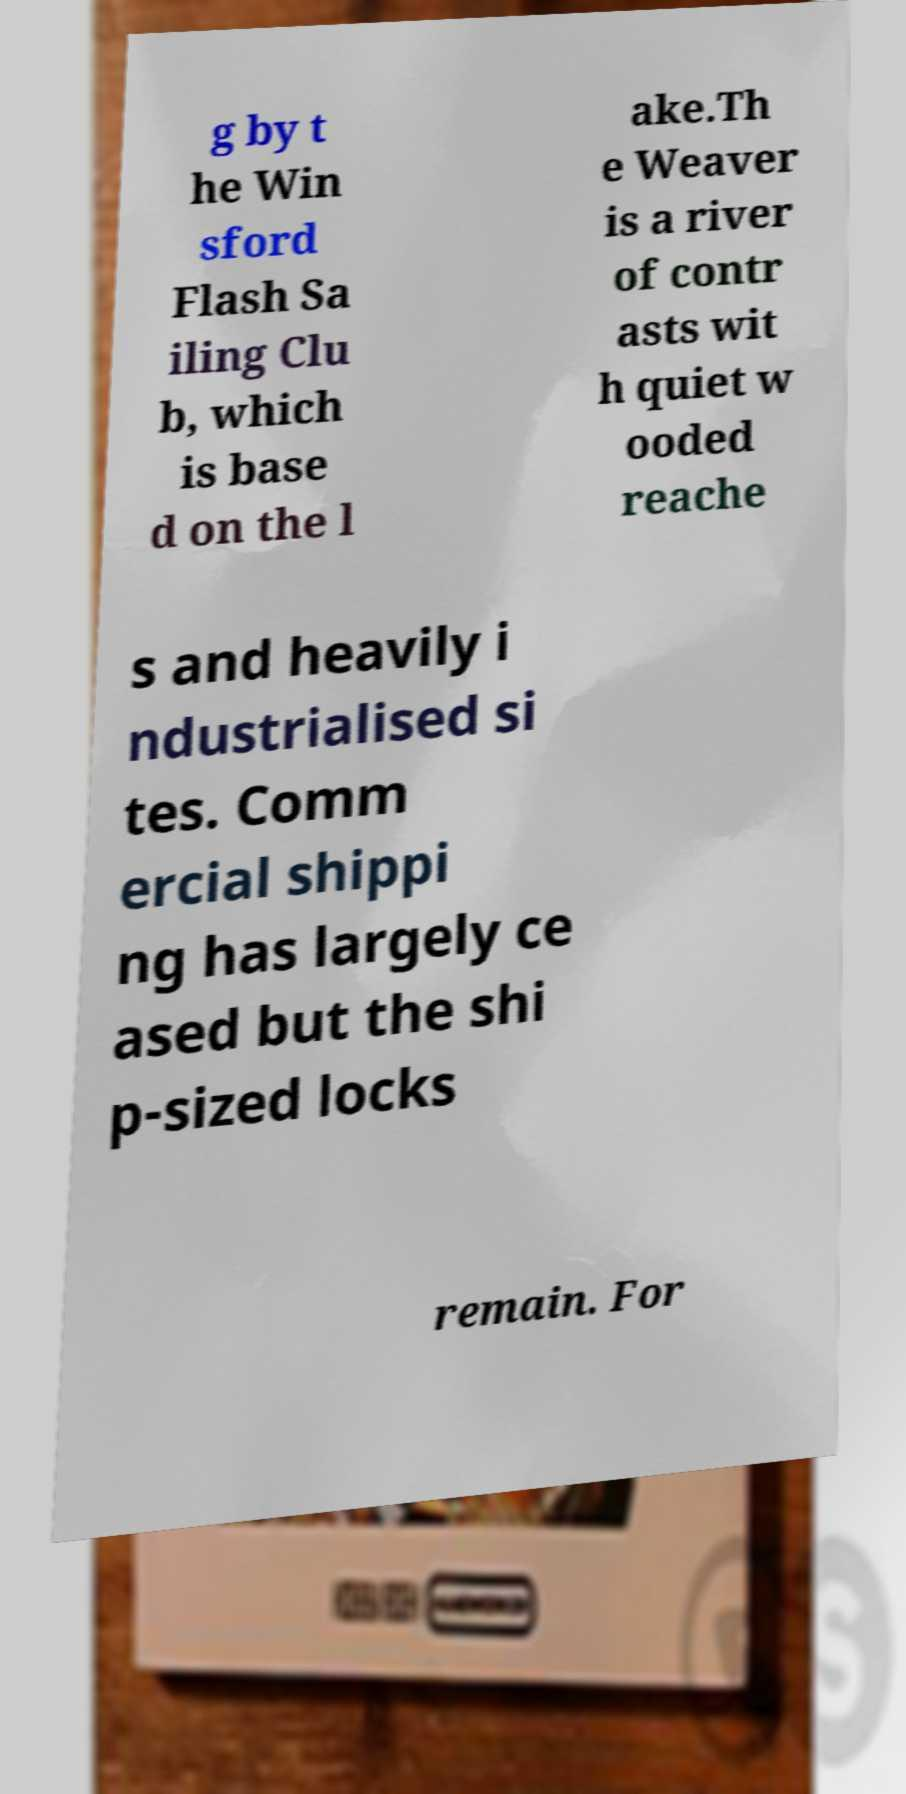There's text embedded in this image that I need extracted. Can you transcribe it verbatim? g by t he Win sford Flash Sa iling Clu b, which is base d on the l ake.Th e Weaver is a river of contr asts wit h quiet w ooded reache s and heavily i ndustrialised si tes. Comm ercial shippi ng has largely ce ased but the shi p-sized locks remain. For 